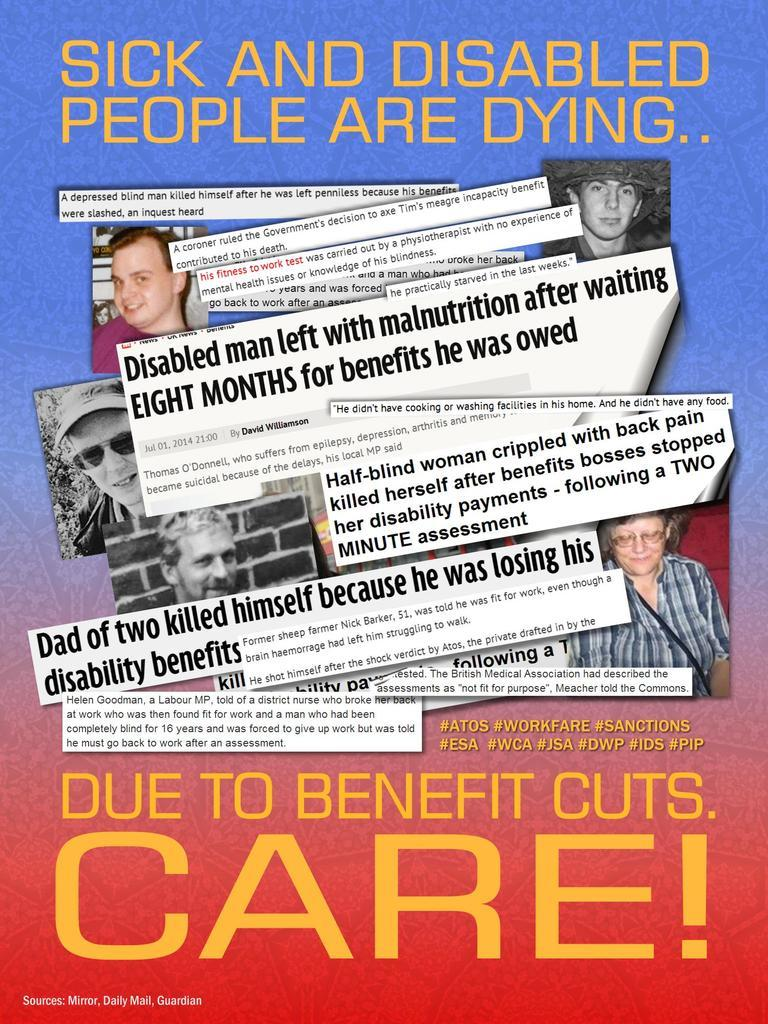<image>
Create a compact narrative representing the image presented. A poster says that sick and disabled people are dying because of benefit cuts. 